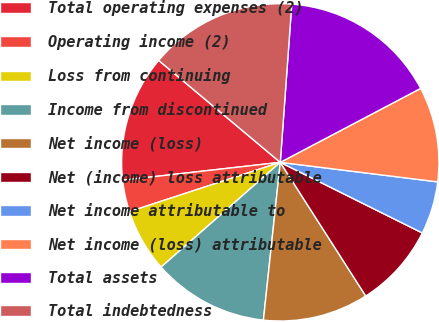Convert chart. <chart><loc_0><loc_0><loc_500><loc_500><pie_chart><fcel>Total operating expenses (2)<fcel>Operating income (2)<fcel>Loss from continuing<fcel>Income from discontinued<fcel>Net income (loss)<fcel>Net (income) loss attributable<fcel>Net income attributable to<fcel>Net income (loss) attributable<fcel>Total assets<fcel>Total indebtedness<nl><fcel>12.9%<fcel>3.23%<fcel>6.45%<fcel>11.83%<fcel>10.75%<fcel>8.6%<fcel>5.38%<fcel>9.68%<fcel>16.13%<fcel>15.05%<nl></chart> 